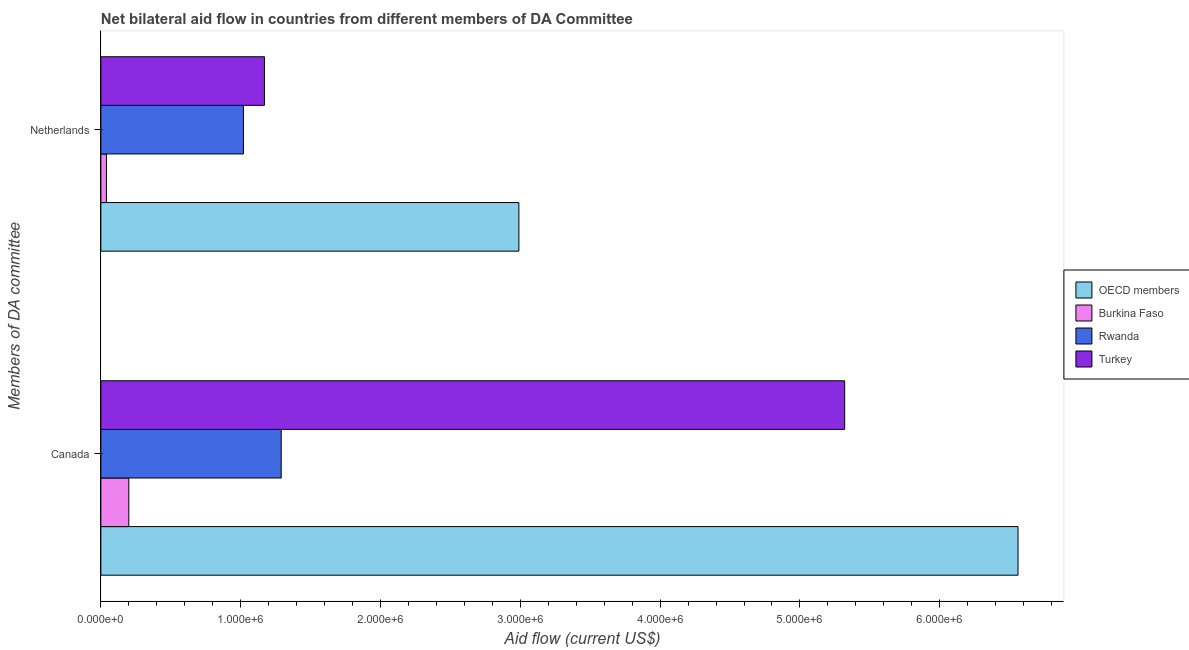Are the number of bars per tick equal to the number of legend labels?
Your response must be concise. Yes. Are the number of bars on each tick of the Y-axis equal?
Keep it short and to the point. Yes. What is the amount of aid given by canada in Burkina Faso?
Ensure brevity in your answer.  2.00e+05. Across all countries, what is the maximum amount of aid given by netherlands?
Provide a succinct answer. 2.99e+06. Across all countries, what is the minimum amount of aid given by netherlands?
Make the answer very short. 4.00e+04. In which country was the amount of aid given by netherlands minimum?
Your answer should be compact. Burkina Faso. What is the total amount of aid given by canada in the graph?
Make the answer very short. 1.34e+07. What is the difference between the amount of aid given by canada in Rwanda and that in Turkey?
Ensure brevity in your answer.  -4.03e+06. What is the difference between the amount of aid given by canada in Rwanda and the amount of aid given by netherlands in Burkina Faso?
Your response must be concise. 1.25e+06. What is the average amount of aid given by canada per country?
Give a very brief answer. 3.34e+06. What is the difference between the amount of aid given by netherlands and amount of aid given by canada in OECD members?
Make the answer very short. -3.57e+06. What is the ratio of the amount of aid given by netherlands in Turkey to that in Rwanda?
Ensure brevity in your answer.  1.15. Is the amount of aid given by netherlands in Burkina Faso less than that in OECD members?
Keep it short and to the point. Yes. What does the 2nd bar from the top in Canada represents?
Offer a terse response. Rwanda. What does the 4th bar from the bottom in Netherlands represents?
Offer a terse response. Turkey. How many countries are there in the graph?
Your response must be concise. 4. What is the difference between two consecutive major ticks on the X-axis?
Keep it short and to the point. 1.00e+06. Are the values on the major ticks of X-axis written in scientific E-notation?
Provide a succinct answer. Yes. Does the graph contain grids?
Make the answer very short. No. How many legend labels are there?
Your answer should be compact. 4. How are the legend labels stacked?
Offer a terse response. Vertical. What is the title of the graph?
Provide a short and direct response. Net bilateral aid flow in countries from different members of DA Committee. What is the label or title of the X-axis?
Your response must be concise. Aid flow (current US$). What is the label or title of the Y-axis?
Provide a succinct answer. Members of DA committee. What is the Aid flow (current US$) in OECD members in Canada?
Provide a succinct answer. 6.56e+06. What is the Aid flow (current US$) in Burkina Faso in Canada?
Your response must be concise. 2.00e+05. What is the Aid flow (current US$) of Rwanda in Canada?
Make the answer very short. 1.29e+06. What is the Aid flow (current US$) in Turkey in Canada?
Make the answer very short. 5.32e+06. What is the Aid flow (current US$) in OECD members in Netherlands?
Your answer should be very brief. 2.99e+06. What is the Aid flow (current US$) of Rwanda in Netherlands?
Ensure brevity in your answer.  1.02e+06. What is the Aid flow (current US$) of Turkey in Netherlands?
Your response must be concise. 1.17e+06. Across all Members of DA committee, what is the maximum Aid flow (current US$) in OECD members?
Offer a terse response. 6.56e+06. Across all Members of DA committee, what is the maximum Aid flow (current US$) in Burkina Faso?
Your answer should be compact. 2.00e+05. Across all Members of DA committee, what is the maximum Aid flow (current US$) of Rwanda?
Provide a short and direct response. 1.29e+06. Across all Members of DA committee, what is the maximum Aid flow (current US$) of Turkey?
Your response must be concise. 5.32e+06. Across all Members of DA committee, what is the minimum Aid flow (current US$) of OECD members?
Give a very brief answer. 2.99e+06. Across all Members of DA committee, what is the minimum Aid flow (current US$) of Burkina Faso?
Your answer should be very brief. 4.00e+04. Across all Members of DA committee, what is the minimum Aid flow (current US$) in Rwanda?
Your answer should be compact. 1.02e+06. Across all Members of DA committee, what is the minimum Aid flow (current US$) of Turkey?
Your answer should be compact. 1.17e+06. What is the total Aid flow (current US$) of OECD members in the graph?
Provide a succinct answer. 9.55e+06. What is the total Aid flow (current US$) of Burkina Faso in the graph?
Provide a short and direct response. 2.40e+05. What is the total Aid flow (current US$) in Rwanda in the graph?
Provide a succinct answer. 2.31e+06. What is the total Aid flow (current US$) in Turkey in the graph?
Offer a very short reply. 6.49e+06. What is the difference between the Aid flow (current US$) in OECD members in Canada and that in Netherlands?
Offer a very short reply. 3.57e+06. What is the difference between the Aid flow (current US$) in Burkina Faso in Canada and that in Netherlands?
Your response must be concise. 1.60e+05. What is the difference between the Aid flow (current US$) in Turkey in Canada and that in Netherlands?
Make the answer very short. 4.15e+06. What is the difference between the Aid flow (current US$) in OECD members in Canada and the Aid flow (current US$) in Burkina Faso in Netherlands?
Your answer should be compact. 6.52e+06. What is the difference between the Aid flow (current US$) in OECD members in Canada and the Aid flow (current US$) in Rwanda in Netherlands?
Keep it short and to the point. 5.54e+06. What is the difference between the Aid flow (current US$) of OECD members in Canada and the Aid flow (current US$) of Turkey in Netherlands?
Offer a terse response. 5.39e+06. What is the difference between the Aid flow (current US$) in Burkina Faso in Canada and the Aid flow (current US$) in Rwanda in Netherlands?
Your answer should be compact. -8.20e+05. What is the difference between the Aid flow (current US$) of Burkina Faso in Canada and the Aid flow (current US$) of Turkey in Netherlands?
Your answer should be compact. -9.70e+05. What is the average Aid flow (current US$) of OECD members per Members of DA committee?
Give a very brief answer. 4.78e+06. What is the average Aid flow (current US$) of Rwanda per Members of DA committee?
Your answer should be compact. 1.16e+06. What is the average Aid flow (current US$) in Turkey per Members of DA committee?
Offer a very short reply. 3.24e+06. What is the difference between the Aid flow (current US$) in OECD members and Aid flow (current US$) in Burkina Faso in Canada?
Offer a very short reply. 6.36e+06. What is the difference between the Aid flow (current US$) in OECD members and Aid flow (current US$) in Rwanda in Canada?
Ensure brevity in your answer.  5.27e+06. What is the difference between the Aid flow (current US$) of OECD members and Aid flow (current US$) of Turkey in Canada?
Keep it short and to the point. 1.24e+06. What is the difference between the Aid flow (current US$) in Burkina Faso and Aid flow (current US$) in Rwanda in Canada?
Offer a very short reply. -1.09e+06. What is the difference between the Aid flow (current US$) of Burkina Faso and Aid flow (current US$) of Turkey in Canada?
Ensure brevity in your answer.  -5.12e+06. What is the difference between the Aid flow (current US$) of Rwanda and Aid flow (current US$) of Turkey in Canada?
Offer a terse response. -4.03e+06. What is the difference between the Aid flow (current US$) of OECD members and Aid flow (current US$) of Burkina Faso in Netherlands?
Ensure brevity in your answer.  2.95e+06. What is the difference between the Aid flow (current US$) of OECD members and Aid flow (current US$) of Rwanda in Netherlands?
Give a very brief answer. 1.97e+06. What is the difference between the Aid flow (current US$) in OECD members and Aid flow (current US$) in Turkey in Netherlands?
Provide a succinct answer. 1.82e+06. What is the difference between the Aid flow (current US$) of Burkina Faso and Aid flow (current US$) of Rwanda in Netherlands?
Provide a short and direct response. -9.80e+05. What is the difference between the Aid flow (current US$) in Burkina Faso and Aid flow (current US$) in Turkey in Netherlands?
Provide a succinct answer. -1.13e+06. What is the difference between the Aid flow (current US$) in Rwanda and Aid flow (current US$) in Turkey in Netherlands?
Your answer should be compact. -1.50e+05. What is the ratio of the Aid flow (current US$) in OECD members in Canada to that in Netherlands?
Your answer should be very brief. 2.19. What is the ratio of the Aid flow (current US$) of Burkina Faso in Canada to that in Netherlands?
Your answer should be compact. 5. What is the ratio of the Aid flow (current US$) in Rwanda in Canada to that in Netherlands?
Make the answer very short. 1.26. What is the ratio of the Aid flow (current US$) of Turkey in Canada to that in Netherlands?
Offer a very short reply. 4.55. What is the difference between the highest and the second highest Aid flow (current US$) of OECD members?
Your answer should be very brief. 3.57e+06. What is the difference between the highest and the second highest Aid flow (current US$) in Rwanda?
Give a very brief answer. 2.70e+05. What is the difference between the highest and the second highest Aid flow (current US$) of Turkey?
Your response must be concise. 4.15e+06. What is the difference between the highest and the lowest Aid flow (current US$) in OECD members?
Keep it short and to the point. 3.57e+06. What is the difference between the highest and the lowest Aid flow (current US$) in Burkina Faso?
Your answer should be very brief. 1.60e+05. What is the difference between the highest and the lowest Aid flow (current US$) in Turkey?
Your response must be concise. 4.15e+06. 